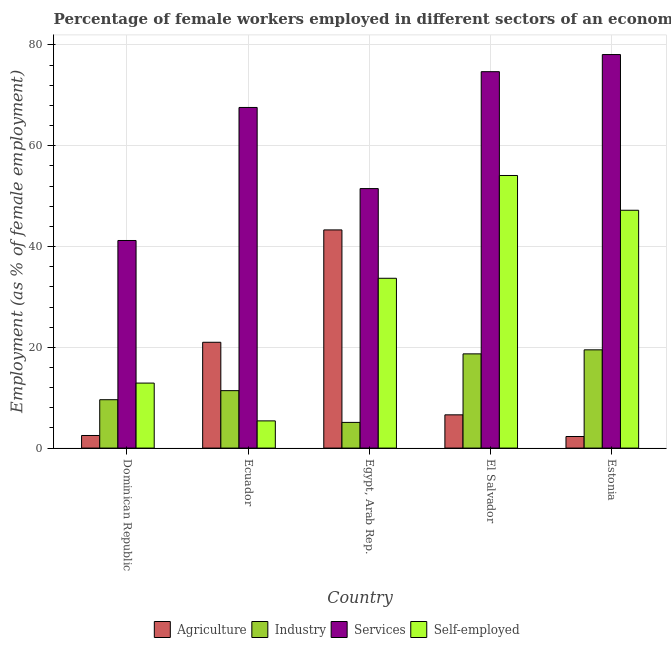How many groups of bars are there?
Ensure brevity in your answer.  5. How many bars are there on the 5th tick from the left?
Make the answer very short. 4. How many bars are there on the 3rd tick from the right?
Your answer should be compact. 4. What is the label of the 4th group of bars from the left?
Your response must be concise. El Salvador. In how many cases, is the number of bars for a given country not equal to the number of legend labels?
Ensure brevity in your answer.  0. What is the percentage of female workers in services in Egypt, Arab Rep.?
Provide a short and direct response. 51.5. Across all countries, what is the maximum percentage of female workers in industry?
Make the answer very short. 19.5. Across all countries, what is the minimum percentage of female workers in agriculture?
Your response must be concise. 2.3. In which country was the percentage of female workers in agriculture maximum?
Your answer should be compact. Egypt, Arab Rep. In which country was the percentage of female workers in industry minimum?
Offer a very short reply. Egypt, Arab Rep. What is the total percentage of female workers in services in the graph?
Provide a succinct answer. 313.1. What is the difference between the percentage of female workers in services in Dominican Republic and that in Estonia?
Your response must be concise. -36.9. What is the difference between the percentage of female workers in agriculture in El Salvador and the percentage of female workers in services in Egypt, Arab Rep.?
Your answer should be very brief. -44.9. What is the average percentage of self employed female workers per country?
Your response must be concise. 30.66. What is the difference between the percentage of female workers in agriculture and percentage of female workers in industry in El Salvador?
Your response must be concise. -12.1. In how many countries, is the percentage of female workers in services greater than 8 %?
Your answer should be very brief. 5. What is the ratio of the percentage of female workers in industry in Dominican Republic to that in Ecuador?
Provide a succinct answer. 0.84. What is the difference between the highest and the second highest percentage of female workers in agriculture?
Provide a short and direct response. 22.3. What is the difference between the highest and the lowest percentage of female workers in services?
Give a very brief answer. 36.9. In how many countries, is the percentage of self employed female workers greater than the average percentage of self employed female workers taken over all countries?
Your answer should be very brief. 3. Is the sum of the percentage of self employed female workers in Egypt, Arab Rep. and El Salvador greater than the maximum percentage of female workers in agriculture across all countries?
Provide a succinct answer. Yes. Is it the case that in every country, the sum of the percentage of self employed female workers and percentage of female workers in services is greater than the sum of percentage of female workers in agriculture and percentage of female workers in industry?
Ensure brevity in your answer.  Yes. What does the 3rd bar from the left in El Salvador represents?
Your response must be concise. Services. What does the 3rd bar from the right in El Salvador represents?
Give a very brief answer. Industry. How many bars are there?
Your answer should be compact. 20. Are all the bars in the graph horizontal?
Make the answer very short. No. How many countries are there in the graph?
Offer a terse response. 5. Are the values on the major ticks of Y-axis written in scientific E-notation?
Offer a very short reply. No. Does the graph contain grids?
Provide a succinct answer. Yes. How are the legend labels stacked?
Offer a terse response. Horizontal. What is the title of the graph?
Provide a short and direct response. Percentage of female workers employed in different sectors of an economy in 2011. Does "Subsidies and Transfers" appear as one of the legend labels in the graph?
Ensure brevity in your answer.  No. What is the label or title of the Y-axis?
Offer a terse response. Employment (as % of female employment). What is the Employment (as % of female employment) in Agriculture in Dominican Republic?
Give a very brief answer. 2.5. What is the Employment (as % of female employment) of Industry in Dominican Republic?
Offer a terse response. 9.6. What is the Employment (as % of female employment) of Services in Dominican Republic?
Offer a terse response. 41.2. What is the Employment (as % of female employment) in Self-employed in Dominican Republic?
Make the answer very short. 12.9. What is the Employment (as % of female employment) in Industry in Ecuador?
Offer a very short reply. 11.4. What is the Employment (as % of female employment) in Services in Ecuador?
Keep it short and to the point. 67.6. What is the Employment (as % of female employment) of Self-employed in Ecuador?
Offer a terse response. 5.4. What is the Employment (as % of female employment) in Agriculture in Egypt, Arab Rep.?
Your answer should be very brief. 43.3. What is the Employment (as % of female employment) in Industry in Egypt, Arab Rep.?
Ensure brevity in your answer.  5.1. What is the Employment (as % of female employment) of Services in Egypt, Arab Rep.?
Give a very brief answer. 51.5. What is the Employment (as % of female employment) in Self-employed in Egypt, Arab Rep.?
Ensure brevity in your answer.  33.7. What is the Employment (as % of female employment) in Agriculture in El Salvador?
Keep it short and to the point. 6.6. What is the Employment (as % of female employment) in Industry in El Salvador?
Make the answer very short. 18.7. What is the Employment (as % of female employment) of Services in El Salvador?
Provide a short and direct response. 74.7. What is the Employment (as % of female employment) of Self-employed in El Salvador?
Your response must be concise. 54.1. What is the Employment (as % of female employment) of Agriculture in Estonia?
Give a very brief answer. 2.3. What is the Employment (as % of female employment) in Industry in Estonia?
Your response must be concise. 19.5. What is the Employment (as % of female employment) of Services in Estonia?
Your response must be concise. 78.1. What is the Employment (as % of female employment) in Self-employed in Estonia?
Offer a very short reply. 47.2. Across all countries, what is the maximum Employment (as % of female employment) of Agriculture?
Keep it short and to the point. 43.3. Across all countries, what is the maximum Employment (as % of female employment) in Services?
Your answer should be very brief. 78.1. Across all countries, what is the maximum Employment (as % of female employment) in Self-employed?
Your response must be concise. 54.1. Across all countries, what is the minimum Employment (as % of female employment) of Agriculture?
Provide a short and direct response. 2.3. Across all countries, what is the minimum Employment (as % of female employment) in Industry?
Make the answer very short. 5.1. Across all countries, what is the minimum Employment (as % of female employment) of Services?
Your response must be concise. 41.2. Across all countries, what is the minimum Employment (as % of female employment) in Self-employed?
Provide a succinct answer. 5.4. What is the total Employment (as % of female employment) in Agriculture in the graph?
Give a very brief answer. 75.7. What is the total Employment (as % of female employment) of Industry in the graph?
Give a very brief answer. 64.3. What is the total Employment (as % of female employment) in Services in the graph?
Give a very brief answer. 313.1. What is the total Employment (as % of female employment) in Self-employed in the graph?
Give a very brief answer. 153.3. What is the difference between the Employment (as % of female employment) in Agriculture in Dominican Republic and that in Ecuador?
Offer a very short reply. -18.5. What is the difference between the Employment (as % of female employment) in Services in Dominican Republic and that in Ecuador?
Keep it short and to the point. -26.4. What is the difference between the Employment (as % of female employment) in Self-employed in Dominican Republic and that in Ecuador?
Offer a very short reply. 7.5. What is the difference between the Employment (as % of female employment) of Agriculture in Dominican Republic and that in Egypt, Arab Rep.?
Make the answer very short. -40.8. What is the difference between the Employment (as % of female employment) in Industry in Dominican Republic and that in Egypt, Arab Rep.?
Your answer should be very brief. 4.5. What is the difference between the Employment (as % of female employment) in Services in Dominican Republic and that in Egypt, Arab Rep.?
Give a very brief answer. -10.3. What is the difference between the Employment (as % of female employment) in Self-employed in Dominican Republic and that in Egypt, Arab Rep.?
Give a very brief answer. -20.8. What is the difference between the Employment (as % of female employment) in Agriculture in Dominican Republic and that in El Salvador?
Ensure brevity in your answer.  -4.1. What is the difference between the Employment (as % of female employment) in Services in Dominican Republic and that in El Salvador?
Your response must be concise. -33.5. What is the difference between the Employment (as % of female employment) of Self-employed in Dominican Republic and that in El Salvador?
Give a very brief answer. -41.2. What is the difference between the Employment (as % of female employment) of Agriculture in Dominican Republic and that in Estonia?
Keep it short and to the point. 0.2. What is the difference between the Employment (as % of female employment) of Industry in Dominican Republic and that in Estonia?
Your response must be concise. -9.9. What is the difference between the Employment (as % of female employment) of Services in Dominican Republic and that in Estonia?
Your response must be concise. -36.9. What is the difference between the Employment (as % of female employment) in Self-employed in Dominican Republic and that in Estonia?
Your answer should be very brief. -34.3. What is the difference between the Employment (as % of female employment) of Agriculture in Ecuador and that in Egypt, Arab Rep.?
Offer a very short reply. -22.3. What is the difference between the Employment (as % of female employment) of Industry in Ecuador and that in Egypt, Arab Rep.?
Give a very brief answer. 6.3. What is the difference between the Employment (as % of female employment) of Self-employed in Ecuador and that in Egypt, Arab Rep.?
Ensure brevity in your answer.  -28.3. What is the difference between the Employment (as % of female employment) of Agriculture in Ecuador and that in El Salvador?
Offer a terse response. 14.4. What is the difference between the Employment (as % of female employment) in Services in Ecuador and that in El Salvador?
Your response must be concise. -7.1. What is the difference between the Employment (as % of female employment) in Self-employed in Ecuador and that in El Salvador?
Offer a very short reply. -48.7. What is the difference between the Employment (as % of female employment) of Agriculture in Ecuador and that in Estonia?
Your answer should be very brief. 18.7. What is the difference between the Employment (as % of female employment) of Industry in Ecuador and that in Estonia?
Make the answer very short. -8.1. What is the difference between the Employment (as % of female employment) in Self-employed in Ecuador and that in Estonia?
Provide a succinct answer. -41.8. What is the difference between the Employment (as % of female employment) of Agriculture in Egypt, Arab Rep. and that in El Salvador?
Your answer should be compact. 36.7. What is the difference between the Employment (as % of female employment) of Industry in Egypt, Arab Rep. and that in El Salvador?
Ensure brevity in your answer.  -13.6. What is the difference between the Employment (as % of female employment) of Services in Egypt, Arab Rep. and that in El Salvador?
Provide a succinct answer. -23.2. What is the difference between the Employment (as % of female employment) in Self-employed in Egypt, Arab Rep. and that in El Salvador?
Make the answer very short. -20.4. What is the difference between the Employment (as % of female employment) in Agriculture in Egypt, Arab Rep. and that in Estonia?
Offer a very short reply. 41. What is the difference between the Employment (as % of female employment) in Industry in Egypt, Arab Rep. and that in Estonia?
Your answer should be compact. -14.4. What is the difference between the Employment (as % of female employment) of Services in Egypt, Arab Rep. and that in Estonia?
Give a very brief answer. -26.6. What is the difference between the Employment (as % of female employment) of Agriculture in El Salvador and that in Estonia?
Keep it short and to the point. 4.3. What is the difference between the Employment (as % of female employment) in Services in El Salvador and that in Estonia?
Your answer should be very brief. -3.4. What is the difference between the Employment (as % of female employment) of Agriculture in Dominican Republic and the Employment (as % of female employment) of Industry in Ecuador?
Give a very brief answer. -8.9. What is the difference between the Employment (as % of female employment) in Agriculture in Dominican Republic and the Employment (as % of female employment) in Services in Ecuador?
Your answer should be compact. -65.1. What is the difference between the Employment (as % of female employment) of Agriculture in Dominican Republic and the Employment (as % of female employment) of Self-employed in Ecuador?
Your answer should be very brief. -2.9. What is the difference between the Employment (as % of female employment) in Industry in Dominican Republic and the Employment (as % of female employment) in Services in Ecuador?
Your answer should be very brief. -58. What is the difference between the Employment (as % of female employment) in Industry in Dominican Republic and the Employment (as % of female employment) in Self-employed in Ecuador?
Offer a terse response. 4.2. What is the difference between the Employment (as % of female employment) in Services in Dominican Republic and the Employment (as % of female employment) in Self-employed in Ecuador?
Ensure brevity in your answer.  35.8. What is the difference between the Employment (as % of female employment) of Agriculture in Dominican Republic and the Employment (as % of female employment) of Services in Egypt, Arab Rep.?
Ensure brevity in your answer.  -49. What is the difference between the Employment (as % of female employment) in Agriculture in Dominican Republic and the Employment (as % of female employment) in Self-employed in Egypt, Arab Rep.?
Keep it short and to the point. -31.2. What is the difference between the Employment (as % of female employment) of Industry in Dominican Republic and the Employment (as % of female employment) of Services in Egypt, Arab Rep.?
Ensure brevity in your answer.  -41.9. What is the difference between the Employment (as % of female employment) of Industry in Dominican Republic and the Employment (as % of female employment) of Self-employed in Egypt, Arab Rep.?
Give a very brief answer. -24.1. What is the difference between the Employment (as % of female employment) in Agriculture in Dominican Republic and the Employment (as % of female employment) in Industry in El Salvador?
Offer a terse response. -16.2. What is the difference between the Employment (as % of female employment) in Agriculture in Dominican Republic and the Employment (as % of female employment) in Services in El Salvador?
Make the answer very short. -72.2. What is the difference between the Employment (as % of female employment) in Agriculture in Dominican Republic and the Employment (as % of female employment) in Self-employed in El Salvador?
Your response must be concise. -51.6. What is the difference between the Employment (as % of female employment) of Industry in Dominican Republic and the Employment (as % of female employment) of Services in El Salvador?
Your answer should be compact. -65.1. What is the difference between the Employment (as % of female employment) in Industry in Dominican Republic and the Employment (as % of female employment) in Self-employed in El Salvador?
Your answer should be very brief. -44.5. What is the difference between the Employment (as % of female employment) of Agriculture in Dominican Republic and the Employment (as % of female employment) of Industry in Estonia?
Offer a terse response. -17. What is the difference between the Employment (as % of female employment) in Agriculture in Dominican Republic and the Employment (as % of female employment) in Services in Estonia?
Provide a short and direct response. -75.6. What is the difference between the Employment (as % of female employment) of Agriculture in Dominican Republic and the Employment (as % of female employment) of Self-employed in Estonia?
Give a very brief answer. -44.7. What is the difference between the Employment (as % of female employment) of Industry in Dominican Republic and the Employment (as % of female employment) of Services in Estonia?
Keep it short and to the point. -68.5. What is the difference between the Employment (as % of female employment) of Industry in Dominican Republic and the Employment (as % of female employment) of Self-employed in Estonia?
Your answer should be very brief. -37.6. What is the difference between the Employment (as % of female employment) in Agriculture in Ecuador and the Employment (as % of female employment) in Industry in Egypt, Arab Rep.?
Keep it short and to the point. 15.9. What is the difference between the Employment (as % of female employment) in Agriculture in Ecuador and the Employment (as % of female employment) in Services in Egypt, Arab Rep.?
Offer a very short reply. -30.5. What is the difference between the Employment (as % of female employment) in Industry in Ecuador and the Employment (as % of female employment) in Services in Egypt, Arab Rep.?
Keep it short and to the point. -40.1. What is the difference between the Employment (as % of female employment) in Industry in Ecuador and the Employment (as % of female employment) in Self-employed in Egypt, Arab Rep.?
Provide a succinct answer. -22.3. What is the difference between the Employment (as % of female employment) of Services in Ecuador and the Employment (as % of female employment) of Self-employed in Egypt, Arab Rep.?
Provide a succinct answer. 33.9. What is the difference between the Employment (as % of female employment) of Agriculture in Ecuador and the Employment (as % of female employment) of Services in El Salvador?
Offer a terse response. -53.7. What is the difference between the Employment (as % of female employment) in Agriculture in Ecuador and the Employment (as % of female employment) in Self-employed in El Salvador?
Offer a very short reply. -33.1. What is the difference between the Employment (as % of female employment) of Industry in Ecuador and the Employment (as % of female employment) of Services in El Salvador?
Your response must be concise. -63.3. What is the difference between the Employment (as % of female employment) of Industry in Ecuador and the Employment (as % of female employment) of Self-employed in El Salvador?
Your answer should be very brief. -42.7. What is the difference between the Employment (as % of female employment) of Agriculture in Ecuador and the Employment (as % of female employment) of Industry in Estonia?
Offer a terse response. 1.5. What is the difference between the Employment (as % of female employment) of Agriculture in Ecuador and the Employment (as % of female employment) of Services in Estonia?
Provide a short and direct response. -57.1. What is the difference between the Employment (as % of female employment) of Agriculture in Ecuador and the Employment (as % of female employment) of Self-employed in Estonia?
Offer a very short reply. -26.2. What is the difference between the Employment (as % of female employment) of Industry in Ecuador and the Employment (as % of female employment) of Services in Estonia?
Your response must be concise. -66.7. What is the difference between the Employment (as % of female employment) in Industry in Ecuador and the Employment (as % of female employment) in Self-employed in Estonia?
Your answer should be compact. -35.8. What is the difference between the Employment (as % of female employment) in Services in Ecuador and the Employment (as % of female employment) in Self-employed in Estonia?
Provide a short and direct response. 20.4. What is the difference between the Employment (as % of female employment) in Agriculture in Egypt, Arab Rep. and the Employment (as % of female employment) in Industry in El Salvador?
Give a very brief answer. 24.6. What is the difference between the Employment (as % of female employment) of Agriculture in Egypt, Arab Rep. and the Employment (as % of female employment) of Services in El Salvador?
Your response must be concise. -31.4. What is the difference between the Employment (as % of female employment) of Agriculture in Egypt, Arab Rep. and the Employment (as % of female employment) of Self-employed in El Salvador?
Provide a succinct answer. -10.8. What is the difference between the Employment (as % of female employment) in Industry in Egypt, Arab Rep. and the Employment (as % of female employment) in Services in El Salvador?
Your response must be concise. -69.6. What is the difference between the Employment (as % of female employment) in Industry in Egypt, Arab Rep. and the Employment (as % of female employment) in Self-employed in El Salvador?
Your answer should be very brief. -49. What is the difference between the Employment (as % of female employment) of Agriculture in Egypt, Arab Rep. and the Employment (as % of female employment) of Industry in Estonia?
Offer a very short reply. 23.8. What is the difference between the Employment (as % of female employment) of Agriculture in Egypt, Arab Rep. and the Employment (as % of female employment) of Services in Estonia?
Offer a terse response. -34.8. What is the difference between the Employment (as % of female employment) of Agriculture in Egypt, Arab Rep. and the Employment (as % of female employment) of Self-employed in Estonia?
Your answer should be very brief. -3.9. What is the difference between the Employment (as % of female employment) in Industry in Egypt, Arab Rep. and the Employment (as % of female employment) in Services in Estonia?
Your answer should be very brief. -73. What is the difference between the Employment (as % of female employment) of Industry in Egypt, Arab Rep. and the Employment (as % of female employment) of Self-employed in Estonia?
Offer a very short reply. -42.1. What is the difference between the Employment (as % of female employment) in Agriculture in El Salvador and the Employment (as % of female employment) in Industry in Estonia?
Make the answer very short. -12.9. What is the difference between the Employment (as % of female employment) of Agriculture in El Salvador and the Employment (as % of female employment) of Services in Estonia?
Offer a terse response. -71.5. What is the difference between the Employment (as % of female employment) in Agriculture in El Salvador and the Employment (as % of female employment) in Self-employed in Estonia?
Provide a succinct answer. -40.6. What is the difference between the Employment (as % of female employment) of Industry in El Salvador and the Employment (as % of female employment) of Services in Estonia?
Your answer should be very brief. -59.4. What is the difference between the Employment (as % of female employment) in Industry in El Salvador and the Employment (as % of female employment) in Self-employed in Estonia?
Give a very brief answer. -28.5. What is the difference between the Employment (as % of female employment) of Services in El Salvador and the Employment (as % of female employment) of Self-employed in Estonia?
Provide a succinct answer. 27.5. What is the average Employment (as % of female employment) of Agriculture per country?
Offer a very short reply. 15.14. What is the average Employment (as % of female employment) in Industry per country?
Keep it short and to the point. 12.86. What is the average Employment (as % of female employment) of Services per country?
Provide a succinct answer. 62.62. What is the average Employment (as % of female employment) of Self-employed per country?
Keep it short and to the point. 30.66. What is the difference between the Employment (as % of female employment) of Agriculture and Employment (as % of female employment) of Industry in Dominican Republic?
Offer a terse response. -7.1. What is the difference between the Employment (as % of female employment) of Agriculture and Employment (as % of female employment) of Services in Dominican Republic?
Ensure brevity in your answer.  -38.7. What is the difference between the Employment (as % of female employment) in Industry and Employment (as % of female employment) in Services in Dominican Republic?
Your answer should be compact. -31.6. What is the difference between the Employment (as % of female employment) of Industry and Employment (as % of female employment) of Self-employed in Dominican Republic?
Offer a very short reply. -3.3. What is the difference between the Employment (as % of female employment) of Services and Employment (as % of female employment) of Self-employed in Dominican Republic?
Make the answer very short. 28.3. What is the difference between the Employment (as % of female employment) in Agriculture and Employment (as % of female employment) in Industry in Ecuador?
Provide a short and direct response. 9.6. What is the difference between the Employment (as % of female employment) in Agriculture and Employment (as % of female employment) in Services in Ecuador?
Provide a short and direct response. -46.6. What is the difference between the Employment (as % of female employment) of Industry and Employment (as % of female employment) of Services in Ecuador?
Give a very brief answer. -56.2. What is the difference between the Employment (as % of female employment) in Services and Employment (as % of female employment) in Self-employed in Ecuador?
Ensure brevity in your answer.  62.2. What is the difference between the Employment (as % of female employment) in Agriculture and Employment (as % of female employment) in Industry in Egypt, Arab Rep.?
Provide a succinct answer. 38.2. What is the difference between the Employment (as % of female employment) of Industry and Employment (as % of female employment) of Services in Egypt, Arab Rep.?
Provide a short and direct response. -46.4. What is the difference between the Employment (as % of female employment) in Industry and Employment (as % of female employment) in Self-employed in Egypt, Arab Rep.?
Give a very brief answer. -28.6. What is the difference between the Employment (as % of female employment) in Services and Employment (as % of female employment) in Self-employed in Egypt, Arab Rep.?
Your response must be concise. 17.8. What is the difference between the Employment (as % of female employment) of Agriculture and Employment (as % of female employment) of Industry in El Salvador?
Keep it short and to the point. -12.1. What is the difference between the Employment (as % of female employment) of Agriculture and Employment (as % of female employment) of Services in El Salvador?
Provide a short and direct response. -68.1. What is the difference between the Employment (as % of female employment) in Agriculture and Employment (as % of female employment) in Self-employed in El Salvador?
Provide a succinct answer. -47.5. What is the difference between the Employment (as % of female employment) in Industry and Employment (as % of female employment) in Services in El Salvador?
Offer a terse response. -56. What is the difference between the Employment (as % of female employment) of Industry and Employment (as % of female employment) of Self-employed in El Salvador?
Ensure brevity in your answer.  -35.4. What is the difference between the Employment (as % of female employment) in Services and Employment (as % of female employment) in Self-employed in El Salvador?
Your response must be concise. 20.6. What is the difference between the Employment (as % of female employment) in Agriculture and Employment (as % of female employment) in Industry in Estonia?
Offer a very short reply. -17.2. What is the difference between the Employment (as % of female employment) in Agriculture and Employment (as % of female employment) in Services in Estonia?
Keep it short and to the point. -75.8. What is the difference between the Employment (as % of female employment) in Agriculture and Employment (as % of female employment) in Self-employed in Estonia?
Provide a succinct answer. -44.9. What is the difference between the Employment (as % of female employment) in Industry and Employment (as % of female employment) in Services in Estonia?
Give a very brief answer. -58.6. What is the difference between the Employment (as % of female employment) of Industry and Employment (as % of female employment) of Self-employed in Estonia?
Give a very brief answer. -27.7. What is the difference between the Employment (as % of female employment) in Services and Employment (as % of female employment) in Self-employed in Estonia?
Your response must be concise. 30.9. What is the ratio of the Employment (as % of female employment) of Agriculture in Dominican Republic to that in Ecuador?
Offer a very short reply. 0.12. What is the ratio of the Employment (as % of female employment) in Industry in Dominican Republic to that in Ecuador?
Your response must be concise. 0.84. What is the ratio of the Employment (as % of female employment) in Services in Dominican Republic to that in Ecuador?
Provide a short and direct response. 0.61. What is the ratio of the Employment (as % of female employment) in Self-employed in Dominican Republic to that in Ecuador?
Keep it short and to the point. 2.39. What is the ratio of the Employment (as % of female employment) of Agriculture in Dominican Republic to that in Egypt, Arab Rep.?
Your response must be concise. 0.06. What is the ratio of the Employment (as % of female employment) of Industry in Dominican Republic to that in Egypt, Arab Rep.?
Give a very brief answer. 1.88. What is the ratio of the Employment (as % of female employment) in Services in Dominican Republic to that in Egypt, Arab Rep.?
Keep it short and to the point. 0.8. What is the ratio of the Employment (as % of female employment) in Self-employed in Dominican Republic to that in Egypt, Arab Rep.?
Ensure brevity in your answer.  0.38. What is the ratio of the Employment (as % of female employment) in Agriculture in Dominican Republic to that in El Salvador?
Give a very brief answer. 0.38. What is the ratio of the Employment (as % of female employment) of Industry in Dominican Republic to that in El Salvador?
Offer a terse response. 0.51. What is the ratio of the Employment (as % of female employment) of Services in Dominican Republic to that in El Salvador?
Your answer should be very brief. 0.55. What is the ratio of the Employment (as % of female employment) of Self-employed in Dominican Republic to that in El Salvador?
Make the answer very short. 0.24. What is the ratio of the Employment (as % of female employment) of Agriculture in Dominican Republic to that in Estonia?
Provide a succinct answer. 1.09. What is the ratio of the Employment (as % of female employment) of Industry in Dominican Republic to that in Estonia?
Offer a very short reply. 0.49. What is the ratio of the Employment (as % of female employment) in Services in Dominican Republic to that in Estonia?
Your answer should be very brief. 0.53. What is the ratio of the Employment (as % of female employment) of Self-employed in Dominican Republic to that in Estonia?
Make the answer very short. 0.27. What is the ratio of the Employment (as % of female employment) of Agriculture in Ecuador to that in Egypt, Arab Rep.?
Ensure brevity in your answer.  0.48. What is the ratio of the Employment (as % of female employment) of Industry in Ecuador to that in Egypt, Arab Rep.?
Ensure brevity in your answer.  2.24. What is the ratio of the Employment (as % of female employment) of Services in Ecuador to that in Egypt, Arab Rep.?
Provide a short and direct response. 1.31. What is the ratio of the Employment (as % of female employment) in Self-employed in Ecuador to that in Egypt, Arab Rep.?
Offer a terse response. 0.16. What is the ratio of the Employment (as % of female employment) in Agriculture in Ecuador to that in El Salvador?
Provide a short and direct response. 3.18. What is the ratio of the Employment (as % of female employment) in Industry in Ecuador to that in El Salvador?
Ensure brevity in your answer.  0.61. What is the ratio of the Employment (as % of female employment) of Services in Ecuador to that in El Salvador?
Your answer should be very brief. 0.91. What is the ratio of the Employment (as % of female employment) of Self-employed in Ecuador to that in El Salvador?
Give a very brief answer. 0.1. What is the ratio of the Employment (as % of female employment) of Agriculture in Ecuador to that in Estonia?
Offer a terse response. 9.13. What is the ratio of the Employment (as % of female employment) of Industry in Ecuador to that in Estonia?
Make the answer very short. 0.58. What is the ratio of the Employment (as % of female employment) in Services in Ecuador to that in Estonia?
Provide a succinct answer. 0.87. What is the ratio of the Employment (as % of female employment) of Self-employed in Ecuador to that in Estonia?
Offer a very short reply. 0.11. What is the ratio of the Employment (as % of female employment) in Agriculture in Egypt, Arab Rep. to that in El Salvador?
Provide a succinct answer. 6.56. What is the ratio of the Employment (as % of female employment) in Industry in Egypt, Arab Rep. to that in El Salvador?
Offer a very short reply. 0.27. What is the ratio of the Employment (as % of female employment) of Services in Egypt, Arab Rep. to that in El Salvador?
Keep it short and to the point. 0.69. What is the ratio of the Employment (as % of female employment) of Self-employed in Egypt, Arab Rep. to that in El Salvador?
Give a very brief answer. 0.62. What is the ratio of the Employment (as % of female employment) of Agriculture in Egypt, Arab Rep. to that in Estonia?
Your answer should be very brief. 18.83. What is the ratio of the Employment (as % of female employment) of Industry in Egypt, Arab Rep. to that in Estonia?
Offer a very short reply. 0.26. What is the ratio of the Employment (as % of female employment) of Services in Egypt, Arab Rep. to that in Estonia?
Ensure brevity in your answer.  0.66. What is the ratio of the Employment (as % of female employment) in Self-employed in Egypt, Arab Rep. to that in Estonia?
Provide a succinct answer. 0.71. What is the ratio of the Employment (as % of female employment) in Agriculture in El Salvador to that in Estonia?
Ensure brevity in your answer.  2.87. What is the ratio of the Employment (as % of female employment) of Industry in El Salvador to that in Estonia?
Your answer should be very brief. 0.96. What is the ratio of the Employment (as % of female employment) in Services in El Salvador to that in Estonia?
Offer a terse response. 0.96. What is the ratio of the Employment (as % of female employment) of Self-employed in El Salvador to that in Estonia?
Your response must be concise. 1.15. What is the difference between the highest and the second highest Employment (as % of female employment) in Agriculture?
Your response must be concise. 22.3. What is the difference between the highest and the second highest Employment (as % of female employment) in Services?
Ensure brevity in your answer.  3.4. What is the difference between the highest and the lowest Employment (as % of female employment) in Agriculture?
Offer a terse response. 41. What is the difference between the highest and the lowest Employment (as % of female employment) of Services?
Make the answer very short. 36.9. What is the difference between the highest and the lowest Employment (as % of female employment) in Self-employed?
Provide a succinct answer. 48.7. 